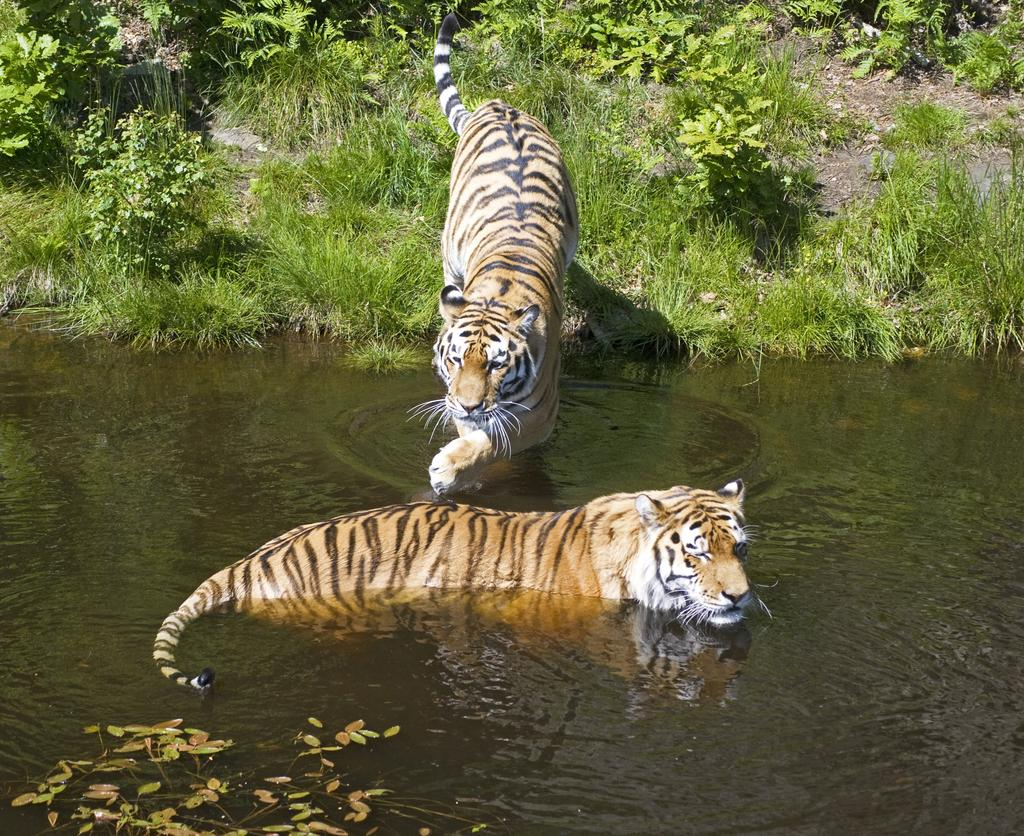What animals can be seen in the water in the image? There are two tigers in the water. What can be seen in the background of the image? There are plants visible in the background. What is the weight of the ladybug on the tiger's back in the image? There is no ladybug present in the image, and therefore no weight can be determined. 